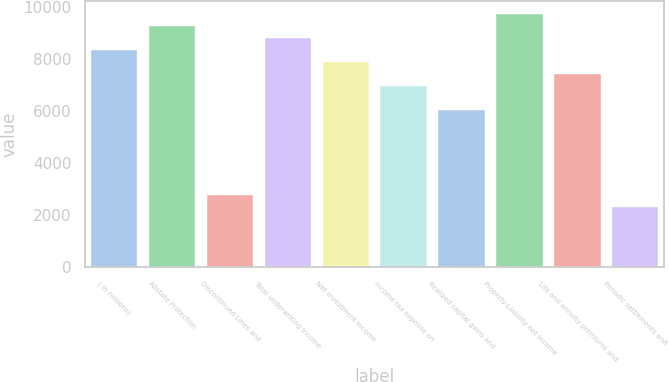Convert chart. <chart><loc_0><loc_0><loc_500><loc_500><bar_chart><fcel>( in millions)<fcel>Allstate Protection<fcel>Discontinued Lines and<fcel>Total underwriting income<fcel>Net investment income<fcel>Income tax expense on<fcel>Realized capital gains and<fcel>Property-Liability net income<fcel>Life and annuity premiums and<fcel>Periodic settlements and<nl><fcel>8343.2<fcel>9270<fcel>2782.4<fcel>8806.6<fcel>7879.8<fcel>6953<fcel>6026.2<fcel>9733.4<fcel>7416.4<fcel>2319<nl></chart> 